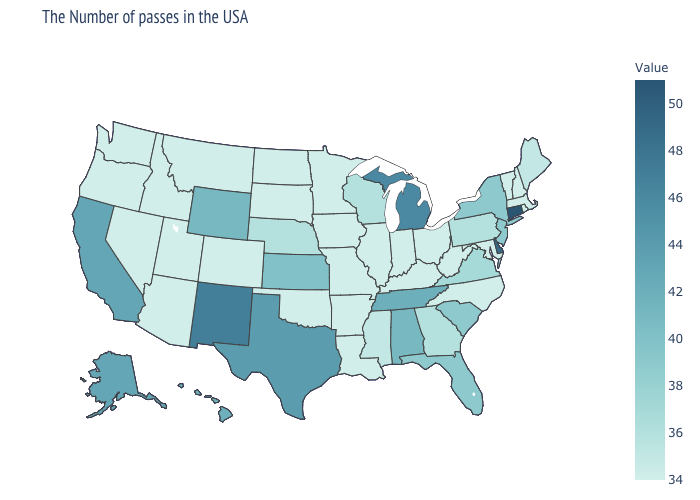Does New Hampshire have the highest value in the Northeast?
Give a very brief answer. No. Among the states that border Virginia , does Tennessee have the lowest value?
Short answer required. No. Does North Dakota have the highest value in the MidWest?
Write a very short answer. No. Does Tennessee have the highest value in the USA?
Write a very short answer. No. Which states have the highest value in the USA?
Be succinct. Connecticut. Among the states that border Virginia , which have the highest value?
Answer briefly. Tennessee. 